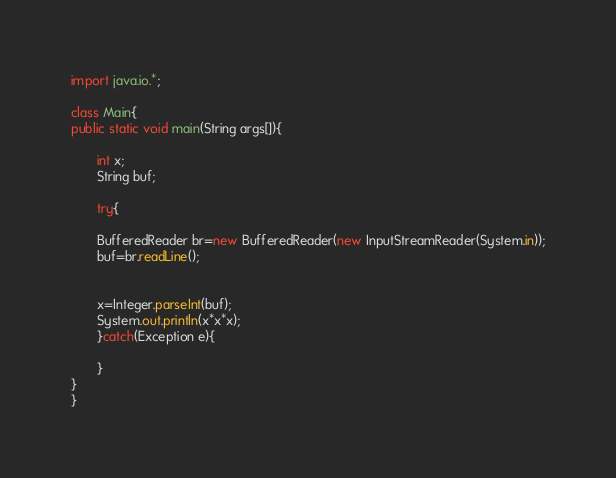<code> <loc_0><loc_0><loc_500><loc_500><_Java_>import java.io.*;

class Main{
public static void main(String args[]){
       
       int x;
       String buf;

       try{

       BufferedReader br=new BufferedReader(new InputStreamReader(System.in));
       buf=br.readLine();

       
       x=Integer.parseInt(buf);
       System.out.println(x*x*x);
       }catch(Exception e){
             
       }
}
}
</code> 